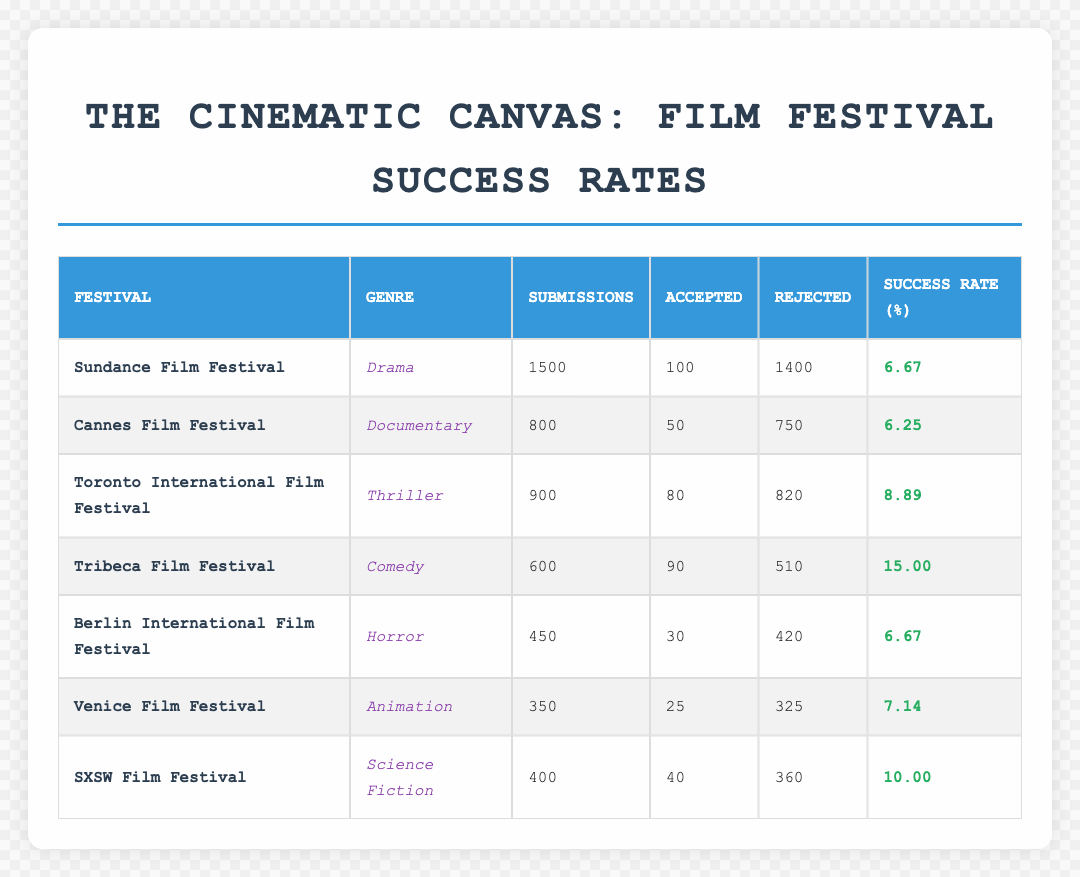What is the success rate of submissions for the Sundance Film Festival? The success rate for the Sundance Film Festival is explicitly listed in the table under the "Success Rate (%)" column, which shows a value of 6.67.
Answer: 6.67 Which genre has the highest success rate at the film festivals listed? To find the genre with the highest success rate, we compare the success rates from the table: Drama (6.67), Documentary (6.25), Thriller (8.89), Comedy (15.00), Horror (6.67), Animation (7.14), and Science Fiction (10.00). The highest among these is Comedy with a success rate of 15.00.
Answer: Comedy What is the total number of accepted films across all the festivals? We add the "Accepted" values from each festival: 100 (Sundance) + 50 (Cannes) + 80 (Toronto) + 90 (Tribeca) + 30 (Berlin) + 25 (Venice) + 40 (SXSW) = 415. Therefore, the total number of accepted films is 415.
Answer: 415 Is the success rate for Animation films greater than for Horror films? The success rate for Animation is 7.14, while the success rate for Horror is 6.67. Since 7.14 is greater than 6.67, the statement is true.
Answer: Yes What is the difference in submissions between the festival with the most submissions and the festival with the least submissions? First, identify the number of submissions: Sundance (1500), Cannes (800), Toronto (900), Tribeca (600), Berlin (450), Venice (350), and SXSW (400). The most submissions are at Sundance (1500), and the least at Venice (350). The difference is calculated as 1500 - 350 = 1150.
Answer: 1150 How many films were rejected at the Tribeca Film Festival? The number of films rejected at Tribeca is directly available in the table, which shows a value of 510 in the "Rejected" column for that festival.
Answer: 510 What is the average success rate of all the film festivals listed? To find the average, we first sum all the success rates: 6.67 + 6.25 + 8.89 + 15.00 + 6.67 + 7.14 + 10.00 = 60.62. Then, we divide by the number of festivals (7): 60.62 / 7 = 8.66. Hence, the average success rate is approximately 8.66.
Answer: 8.66 Is the success rate for Science Fiction submissions higher than the average success rate of all genres combined? We already calculated the average success rate as approximately 8.66. The success rate for Science Fiction is 10.00, which is higher than 8.66. Thus, the answer is true.
Answer: Yes 